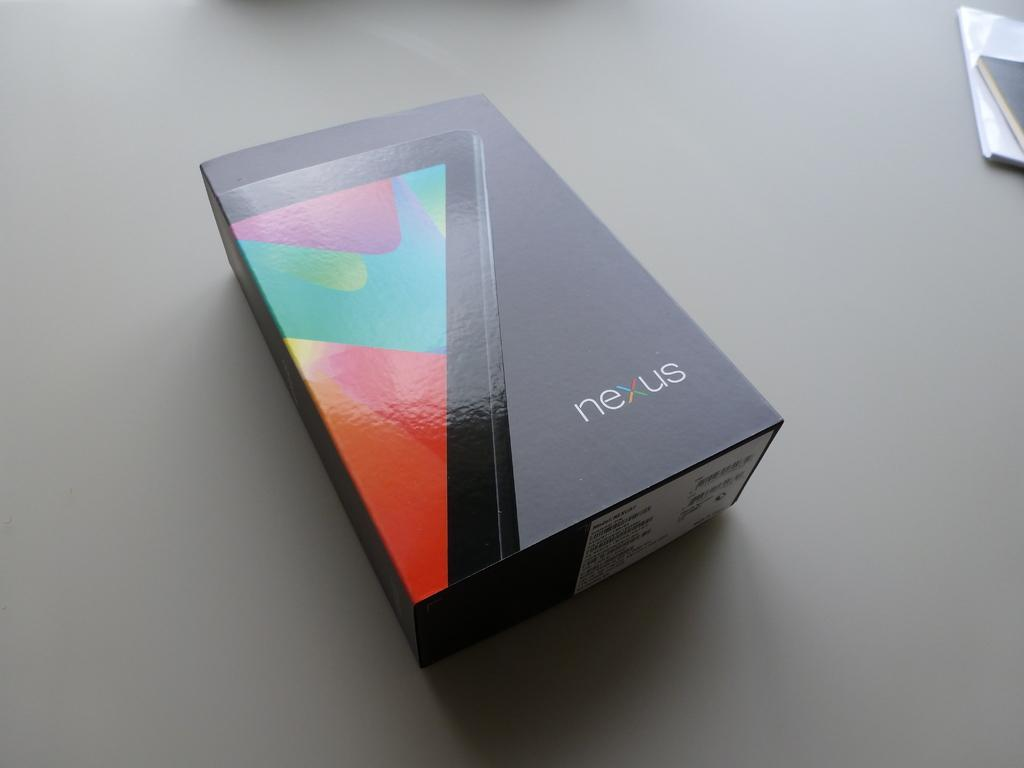<image>
Summarize the visual content of the image. Black box that says NEXUS on it that shows a phone. 